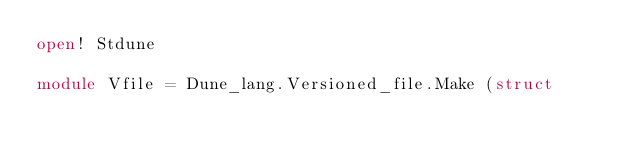Convert code to text. <code><loc_0><loc_0><loc_500><loc_500><_OCaml_>open! Stdune

module Vfile = Dune_lang.Versioned_file.Make (struct</code> 